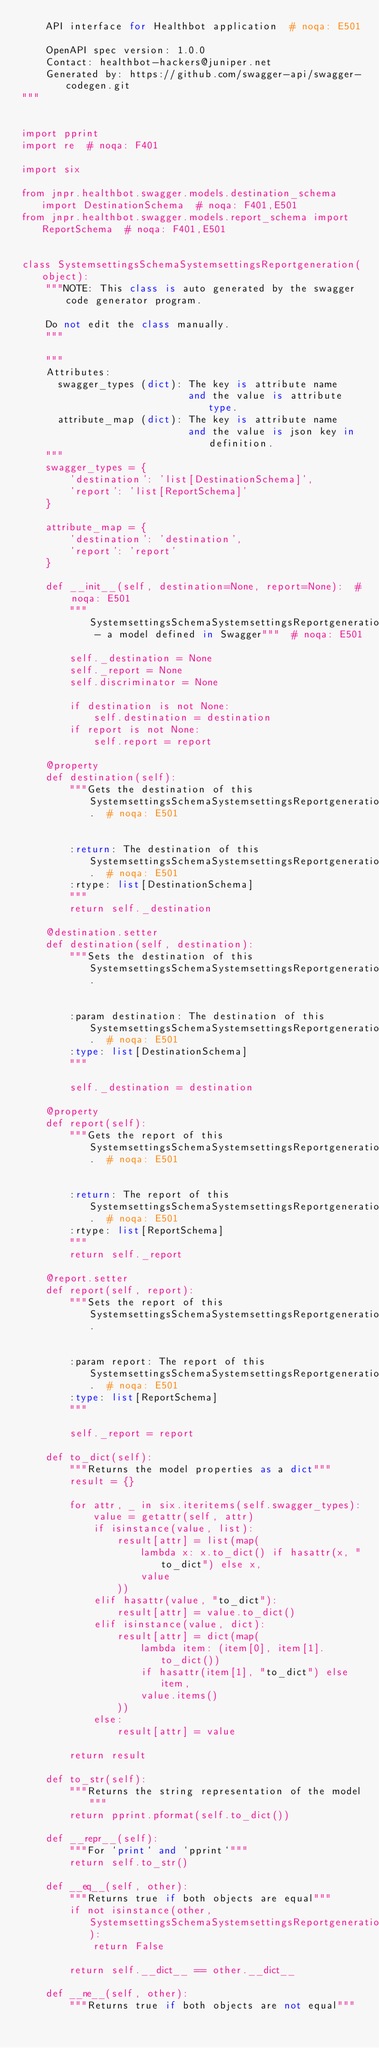Convert code to text. <code><loc_0><loc_0><loc_500><loc_500><_Python_>    API interface for Healthbot application  # noqa: E501

    OpenAPI spec version: 1.0.0
    Contact: healthbot-hackers@juniper.net
    Generated by: https://github.com/swagger-api/swagger-codegen.git
"""


import pprint
import re  # noqa: F401

import six

from jnpr.healthbot.swagger.models.destination_schema import DestinationSchema  # noqa: F401,E501
from jnpr.healthbot.swagger.models.report_schema import ReportSchema  # noqa: F401,E501


class SystemsettingsSchemaSystemsettingsReportgeneration(object):
    """NOTE: This class is auto generated by the swagger code generator program.

    Do not edit the class manually.
    """

    """
    Attributes:
      swagger_types (dict): The key is attribute name
                            and the value is attribute type.
      attribute_map (dict): The key is attribute name
                            and the value is json key in definition.
    """
    swagger_types = {
        'destination': 'list[DestinationSchema]',
        'report': 'list[ReportSchema]'
    }

    attribute_map = {
        'destination': 'destination',
        'report': 'report'
    }

    def __init__(self, destination=None, report=None):  # noqa: E501
        """SystemsettingsSchemaSystemsettingsReportgeneration - a model defined in Swagger"""  # noqa: E501

        self._destination = None
        self._report = None
        self.discriminator = None

        if destination is not None:
            self.destination = destination
        if report is not None:
            self.report = report

    @property
    def destination(self):
        """Gets the destination of this SystemsettingsSchemaSystemsettingsReportgeneration.  # noqa: E501


        :return: The destination of this SystemsettingsSchemaSystemsettingsReportgeneration.  # noqa: E501
        :rtype: list[DestinationSchema]
        """
        return self._destination

    @destination.setter
    def destination(self, destination):
        """Sets the destination of this SystemsettingsSchemaSystemsettingsReportgeneration.


        :param destination: The destination of this SystemsettingsSchemaSystemsettingsReportgeneration.  # noqa: E501
        :type: list[DestinationSchema]
        """

        self._destination = destination

    @property
    def report(self):
        """Gets the report of this SystemsettingsSchemaSystemsettingsReportgeneration.  # noqa: E501


        :return: The report of this SystemsettingsSchemaSystemsettingsReportgeneration.  # noqa: E501
        :rtype: list[ReportSchema]
        """
        return self._report

    @report.setter
    def report(self, report):
        """Sets the report of this SystemsettingsSchemaSystemsettingsReportgeneration.


        :param report: The report of this SystemsettingsSchemaSystemsettingsReportgeneration.  # noqa: E501
        :type: list[ReportSchema]
        """

        self._report = report

    def to_dict(self):
        """Returns the model properties as a dict"""
        result = {}

        for attr, _ in six.iteritems(self.swagger_types):
            value = getattr(self, attr)
            if isinstance(value, list):
                result[attr] = list(map(
                    lambda x: x.to_dict() if hasattr(x, "to_dict") else x,
                    value
                ))
            elif hasattr(value, "to_dict"):
                result[attr] = value.to_dict()
            elif isinstance(value, dict):
                result[attr] = dict(map(
                    lambda item: (item[0], item[1].to_dict())
                    if hasattr(item[1], "to_dict") else item,
                    value.items()
                ))
            else:
                result[attr] = value

        return result

    def to_str(self):
        """Returns the string representation of the model"""
        return pprint.pformat(self.to_dict())

    def __repr__(self):
        """For `print` and `pprint`"""
        return self.to_str()

    def __eq__(self, other):
        """Returns true if both objects are equal"""
        if not isinstance(other, SystemsettingsSchemaSystemsettingsReportgeneration):
            return False

        return self.__dict__ == other.__dict__

    def __ne__(self, other):
        """Returns true if both objects are not equal"""</code> 